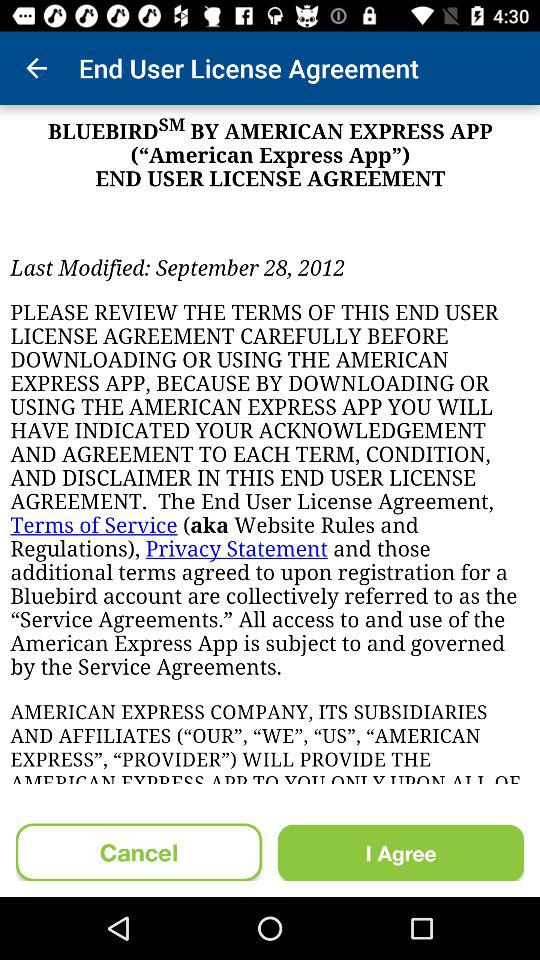What is the post headline? The post headline is "BLUEBIRD BY AMERICAN EXPRESS APP ("American Express App") END USER LICENSE AGREEMENT". 